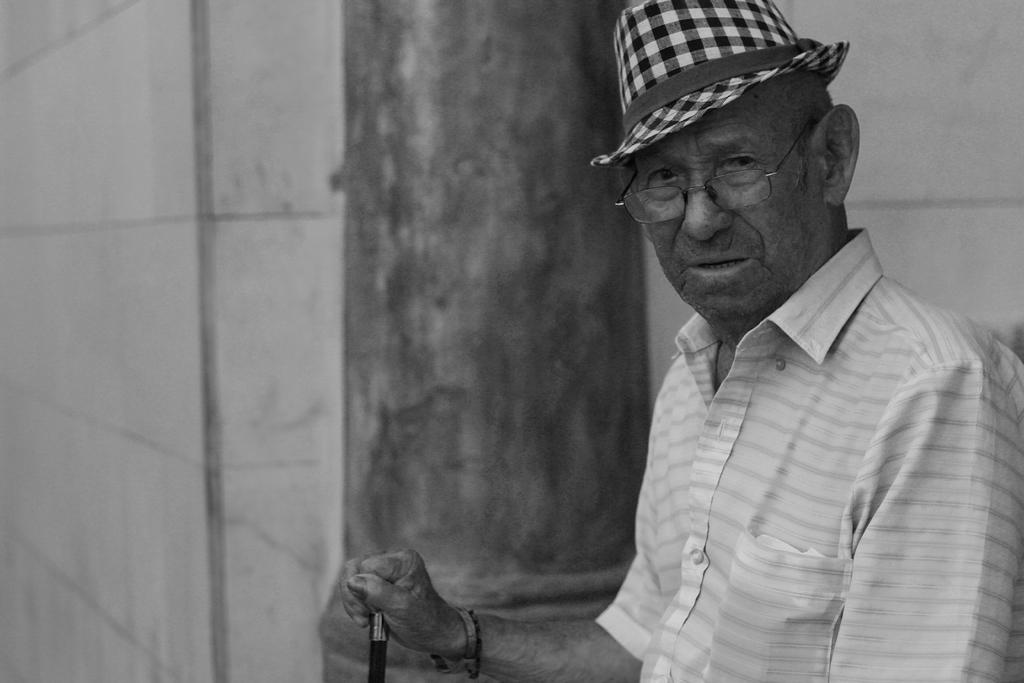What is the color scheme of the image? The image is black and white. What can be seen in the background of the image? There is a wall in the background of the image. What is the person in the image doing? The person is standing near the wall. What other object is visible beside the person? There is a pillar beside the person. What type of garden can be seen in the image? There is no garden present in the image. What color is the zebra in the image? There is no zebra present in the image. 